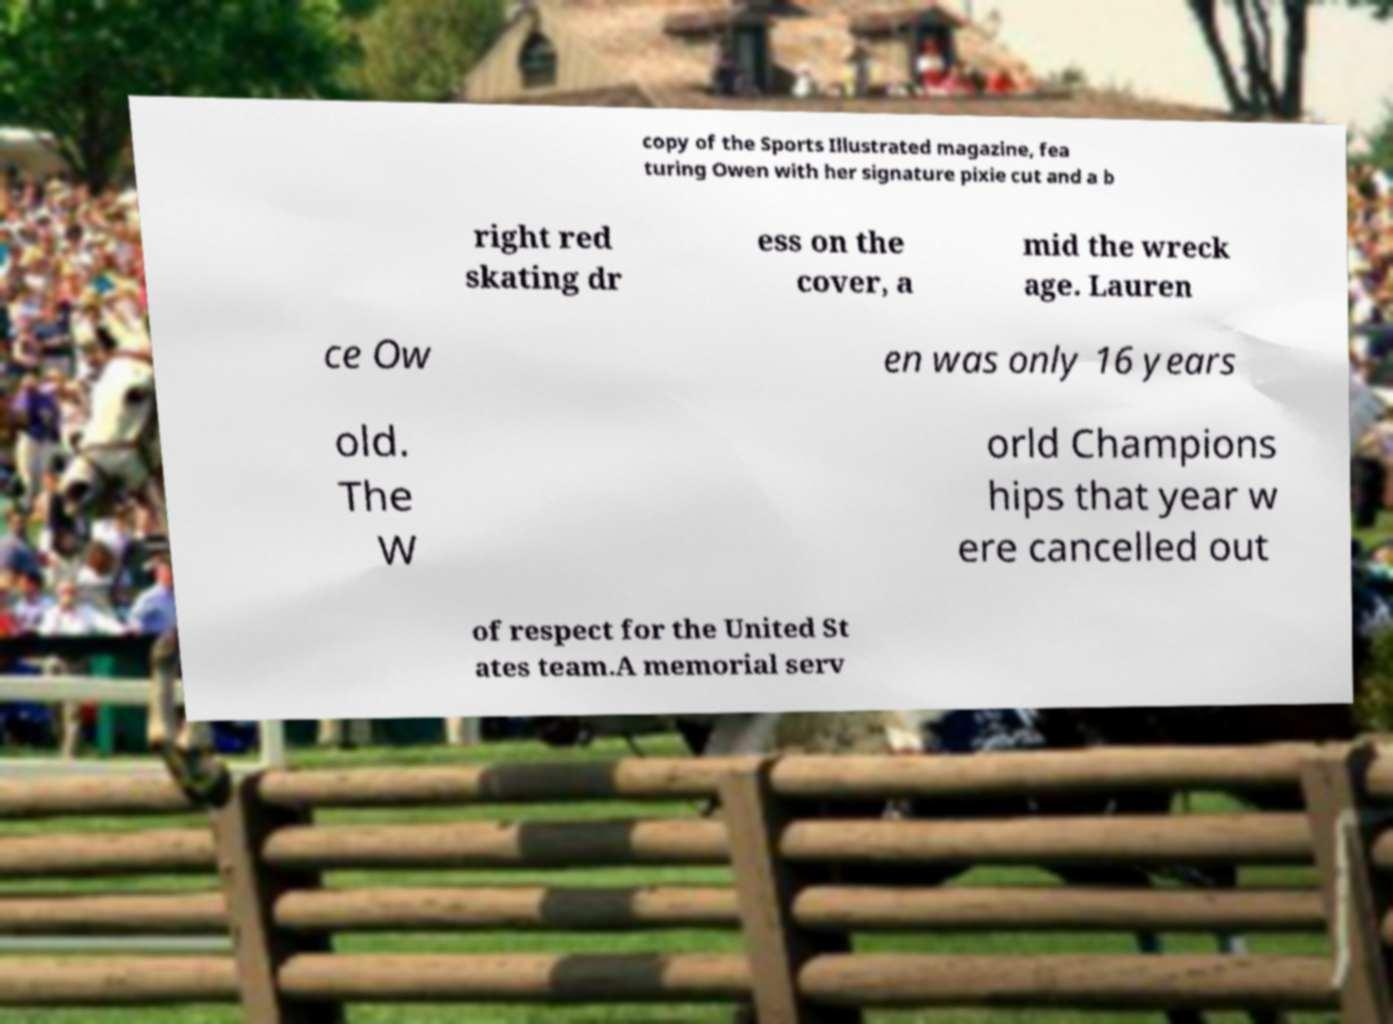Please identify and transcribe the text found in this image. copy of the Sports Illustrated magazine, fea turing Owen with her signature pixie cut and a b right red skating dr ess on the cover, a mid the wreck age. Lauren ce Ow en was only 16 years old. The W orld Champions hips that year w ere cancelled out of respect for the United St ates team.A memorial serv 